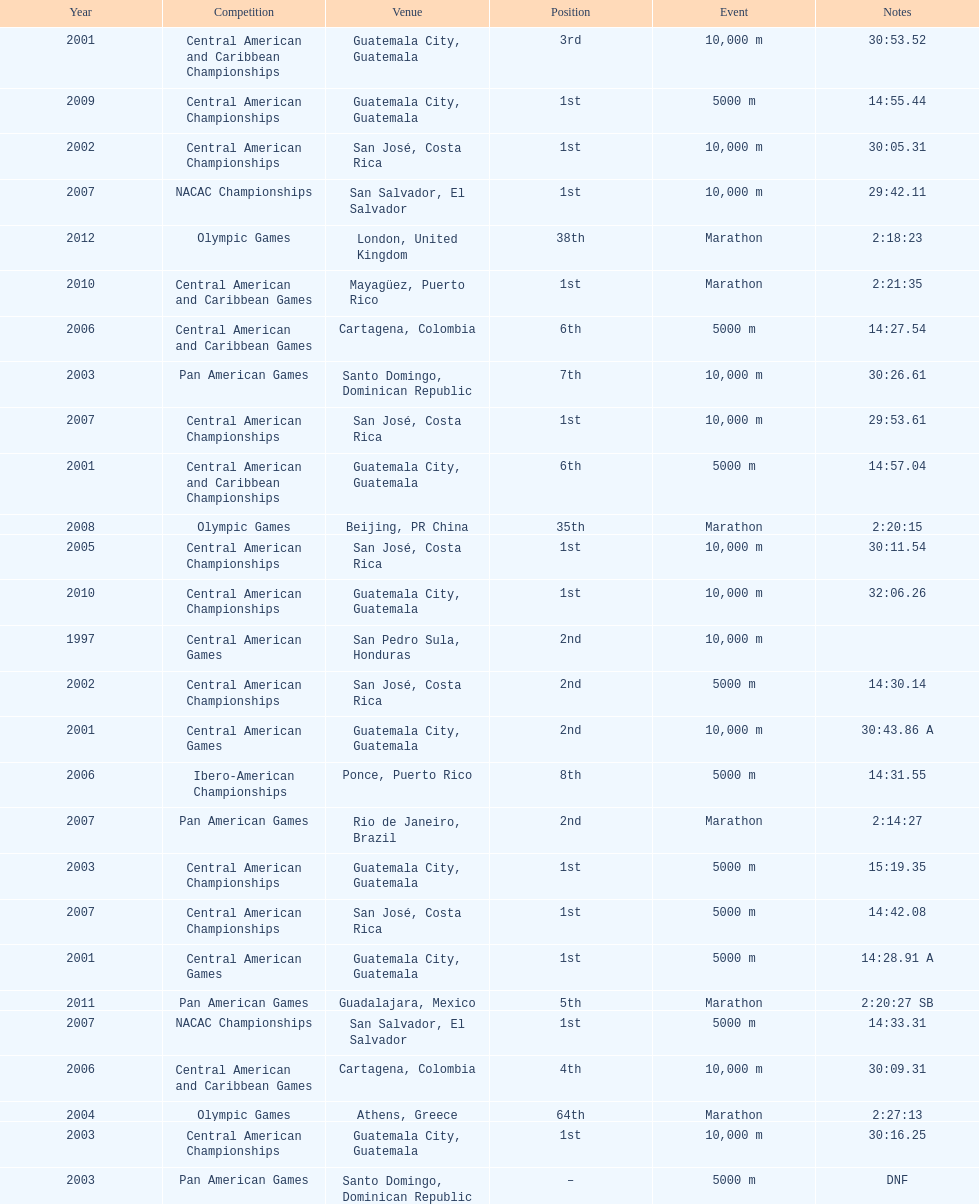Where was the exclusive 64th rank maintained? Athens, Greece. 